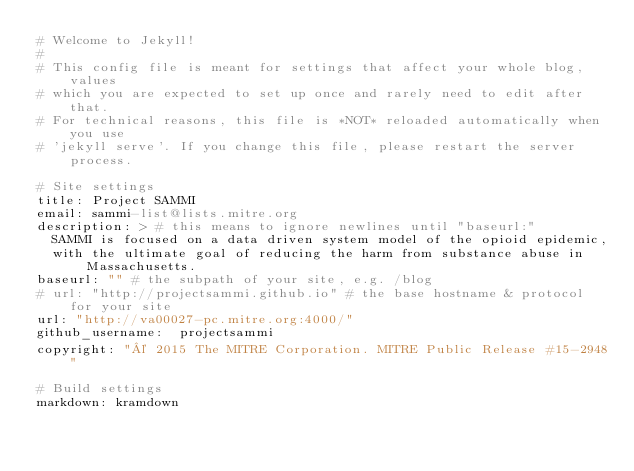<code> <loc_0><loc_0><loc_500><loc_500><_YAML_># Welcome to Jekyll!
#
# This config file is meant for settings that affect your whole blog, values
# which you are expected to set up once and rarely need to edit after that.
# For technical reasons, this file is *NOT* reloaded automatically when you use
# 'jekyll serve'. If you change this file, please restart the server process.

# Site settings
title: Project SAMMI
email: sammi-list@lists.mitre.org
description: > # this means to ignore newlines until "baseurl:"
  SAMMI is focused on a data driven system model of the opioid epidemic,
  with the ultimate goal of reducing the harm from substance abuse in Massachusetts.
baseurl: "" # the subpath of your site, e.g. /blog
# url: "http://projectsammi.github.io" # the base hostname & protocol for your site
url: "http://va00027-pc.mitre.org:4000/"
github_username:  projectsammi
copyright: "© 2015 The MITRE Corporation. MITRE Public Release #15-2948"

# Build settings
markdown: kramdown
</code> 